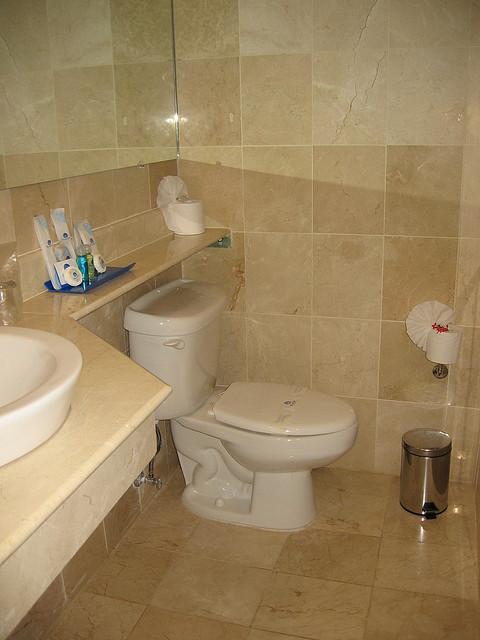Where is the mirror?
Keep it brief. Wall. What kind of room is this?
Write a very short answer. Bathroom. How many rolls of toilet paper are there?
Write a very short answer. 2. Seat, up or down?
Quick response, please. Down. Is the toilet lid down?
Concise answer only. Yes. What is underneath the toilet roll?
Write a very short answer. Trash can. 